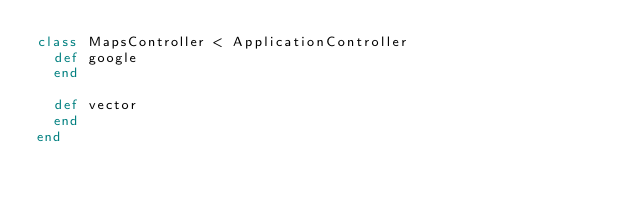<code> <loc_0><loc_0><loc_500><loc_500><_Ruby_>class MapsController < ApplicationController
  def google
  end

  def vector
  end
end
</code> 